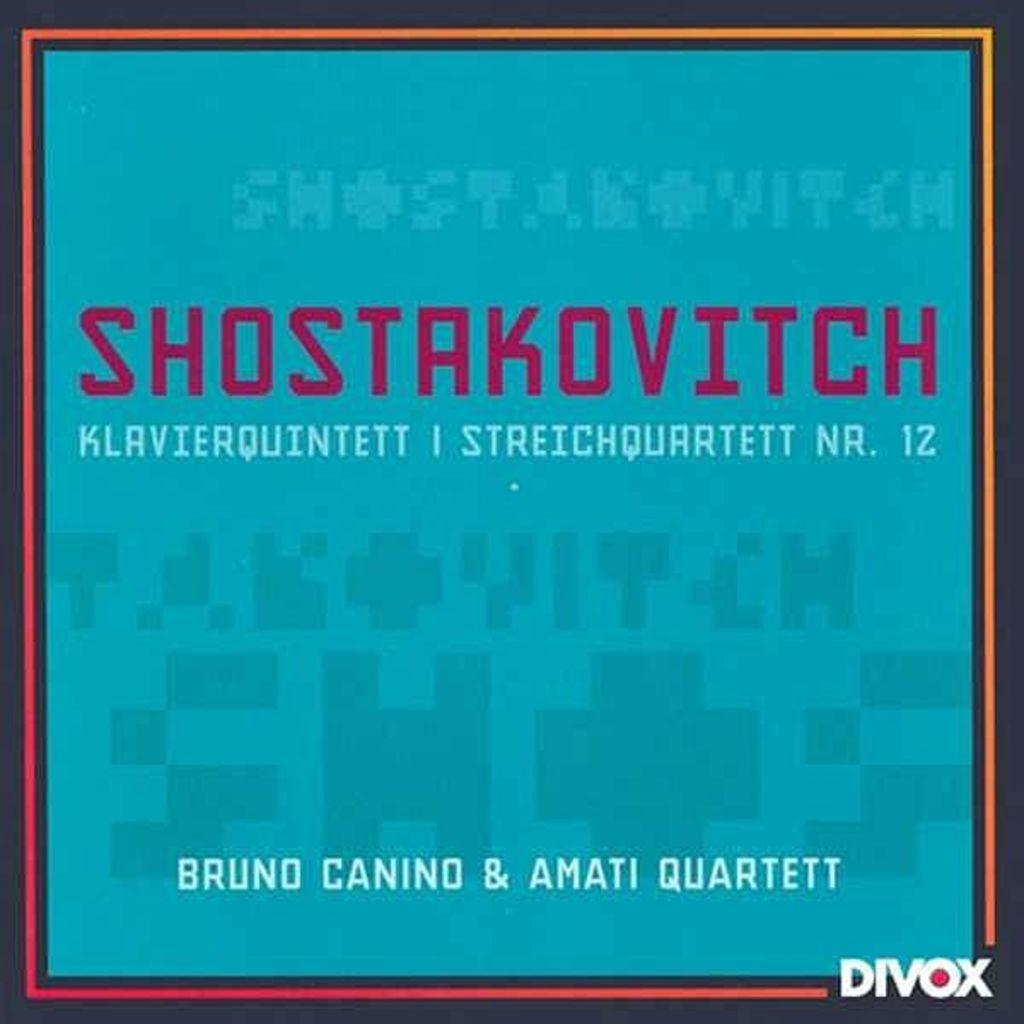<image>
Present a compact description of the photo's key features. A poster advertising Bruno Canino and Amati Quartett 